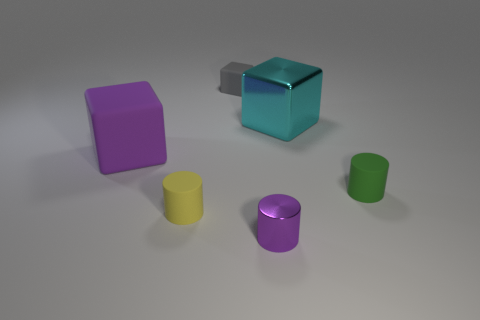There is a metallic thing that is the same color as the big rubber cube; what is its shape?
Your answer should be very brief. Cylinder. Is there anything else that has the same material as the gray block?
Ensure brevity in your answer.  Yes. Do the small matte object that is on the right side of the big cyan metallic thing and the metallic thing behind the small yellow rubber cylinder have the same shape?
Give a very brief answer. No. How many big purple cubes are there?
Make the answer very short. 1. The large object that is the same material as the small green object is what shape?
Your response must be concise. Cube. Are there any other things that are the same color as the large matte cube?
Offer a terse response. Yes. Is the color of the big metallic object the same as the matte cylinder behind the tiny yellow cylinder?
Give a very brief answer. No. Are there fewer tiny purple shiny objects to the right of the purple cylinder than small shiny things?
Your answer should be compact. Yes. What is the material of the cylinder left of the small gray matte block?
Your answer should be compact. Rubber. How many other objects are there of the same size as the purple metal object?
Ensure brevity in your answer.  3. 